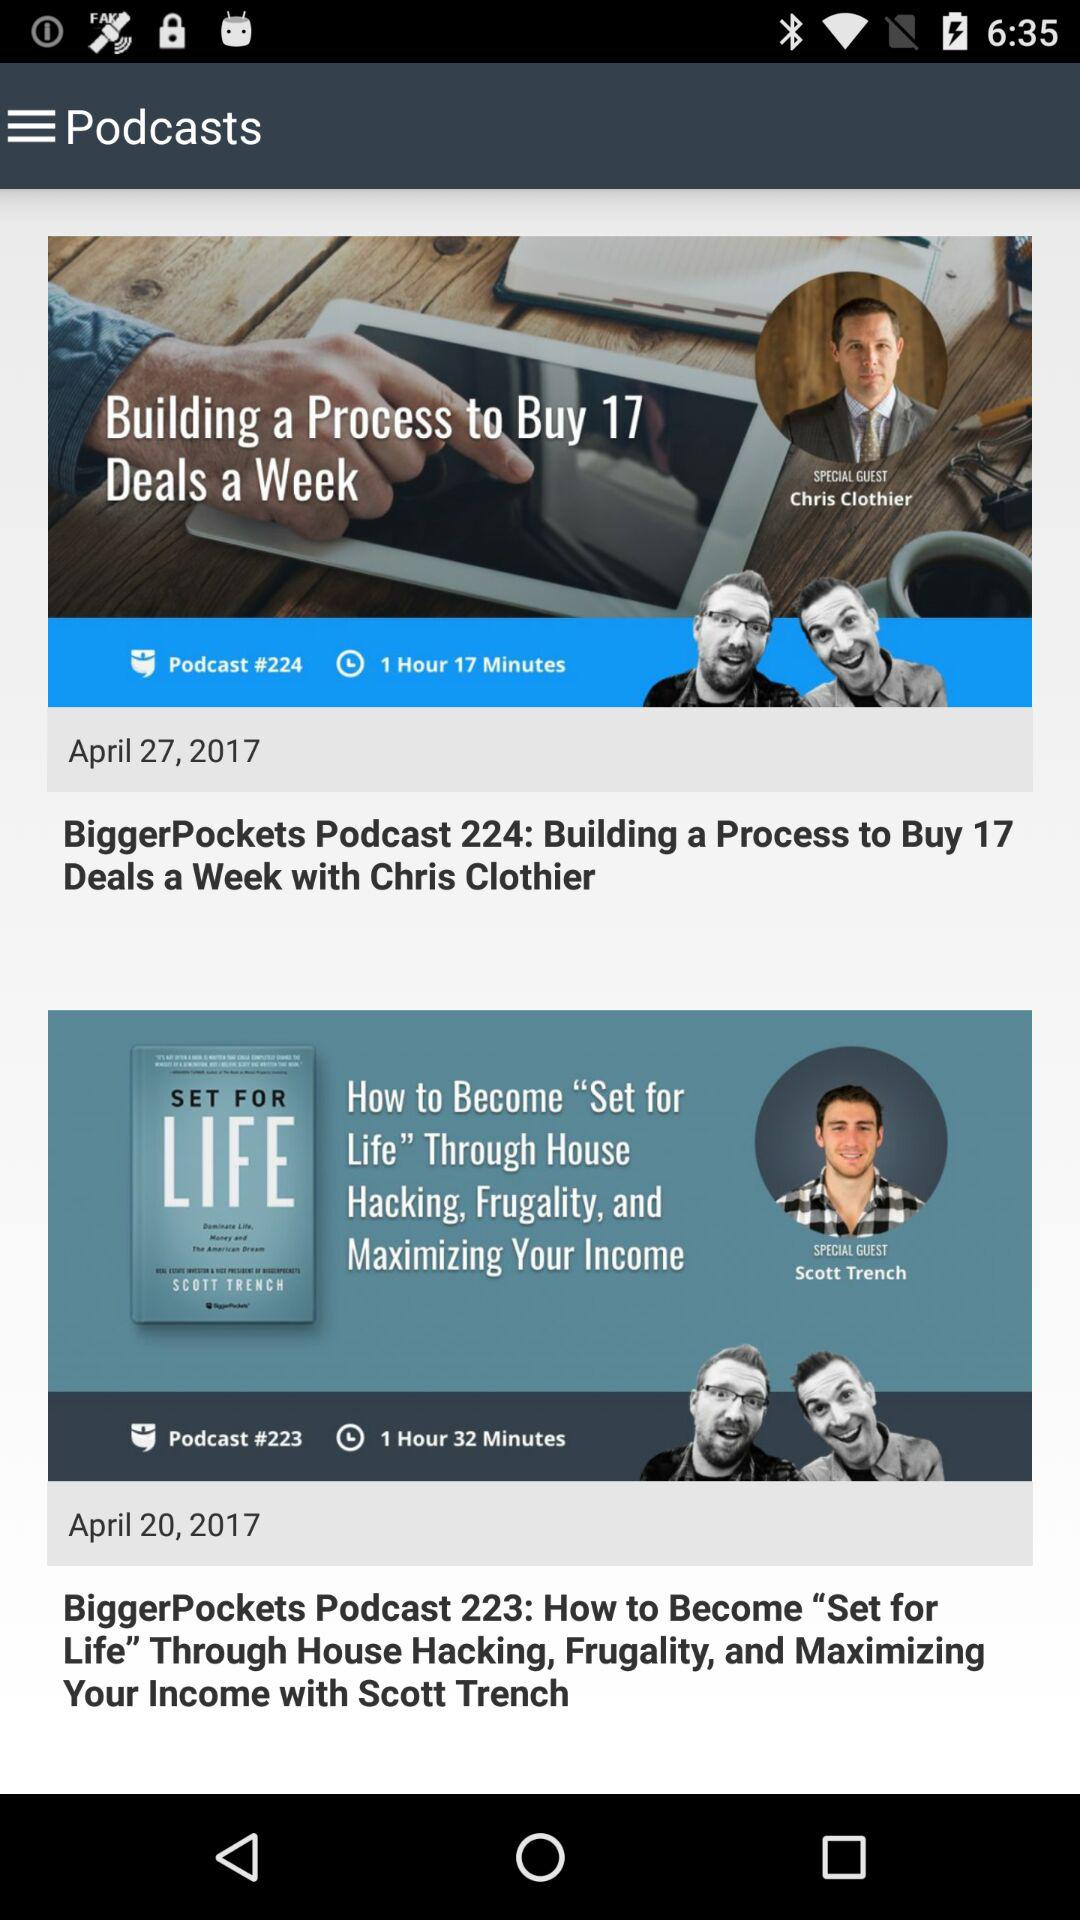Who is the special guest in podcast number 223? The special guest is Scott Trench. 